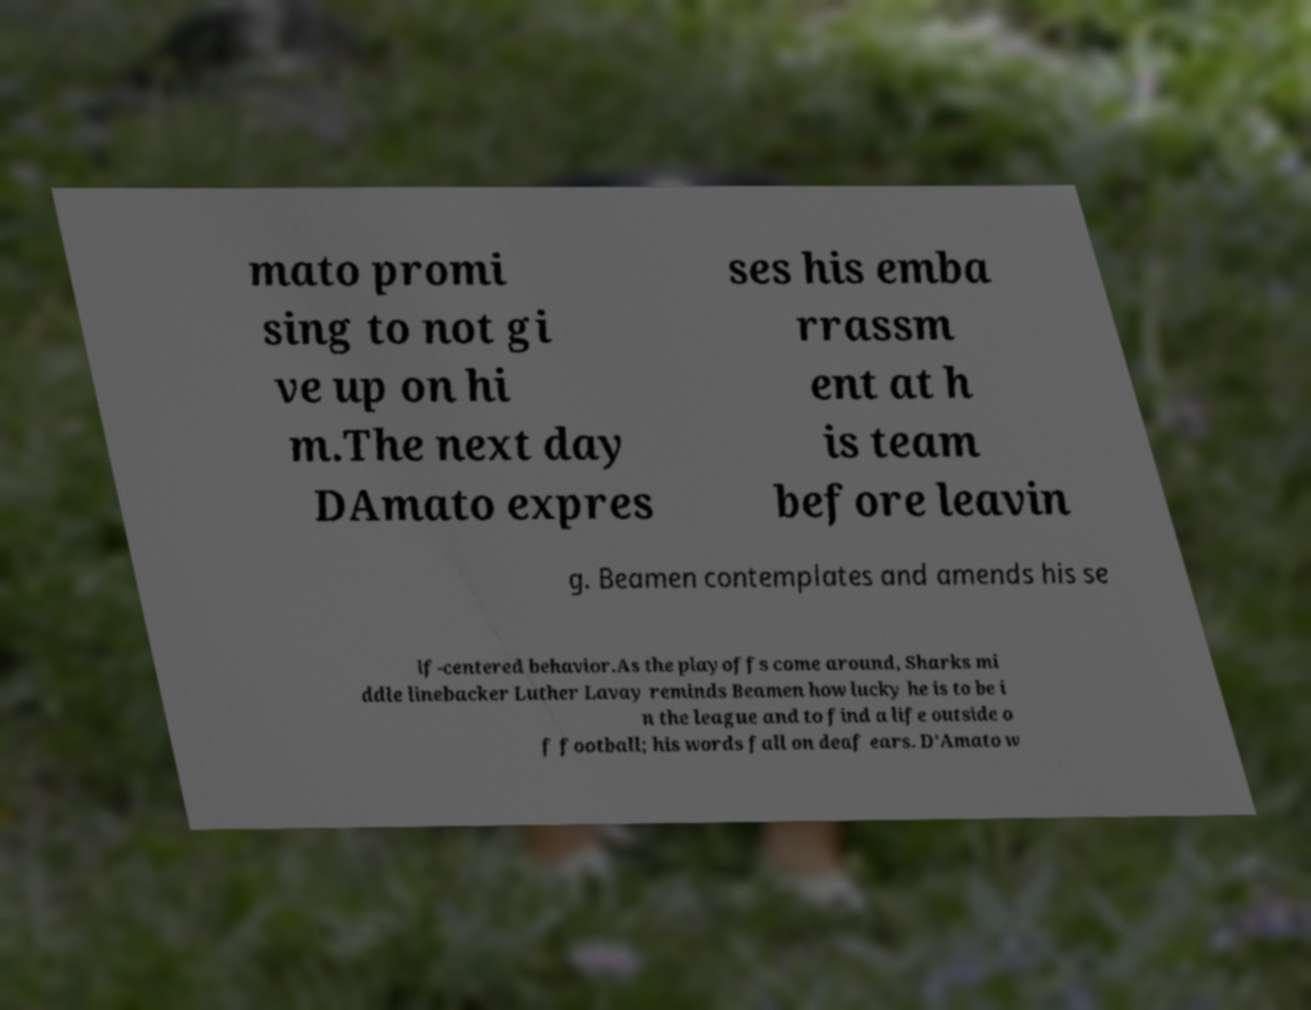Can you read and provide the text displayed in the image?This photo seems to have some interesting text. Can you extract and type it out for me? mato promi sing to not gi ve up on hi m.The next day DAmato expres ses his emba rrassm ent at h is team before leavin g. Beamen contemplates and amends his se lf-centered behavior.As the playoffs come around, Sharks mi ddle linebacker Luther Lavay reminds Beamen how lucky he is to be i n the league and to find a life outside o f football; his words fall on deaf ears. D'Amato w 